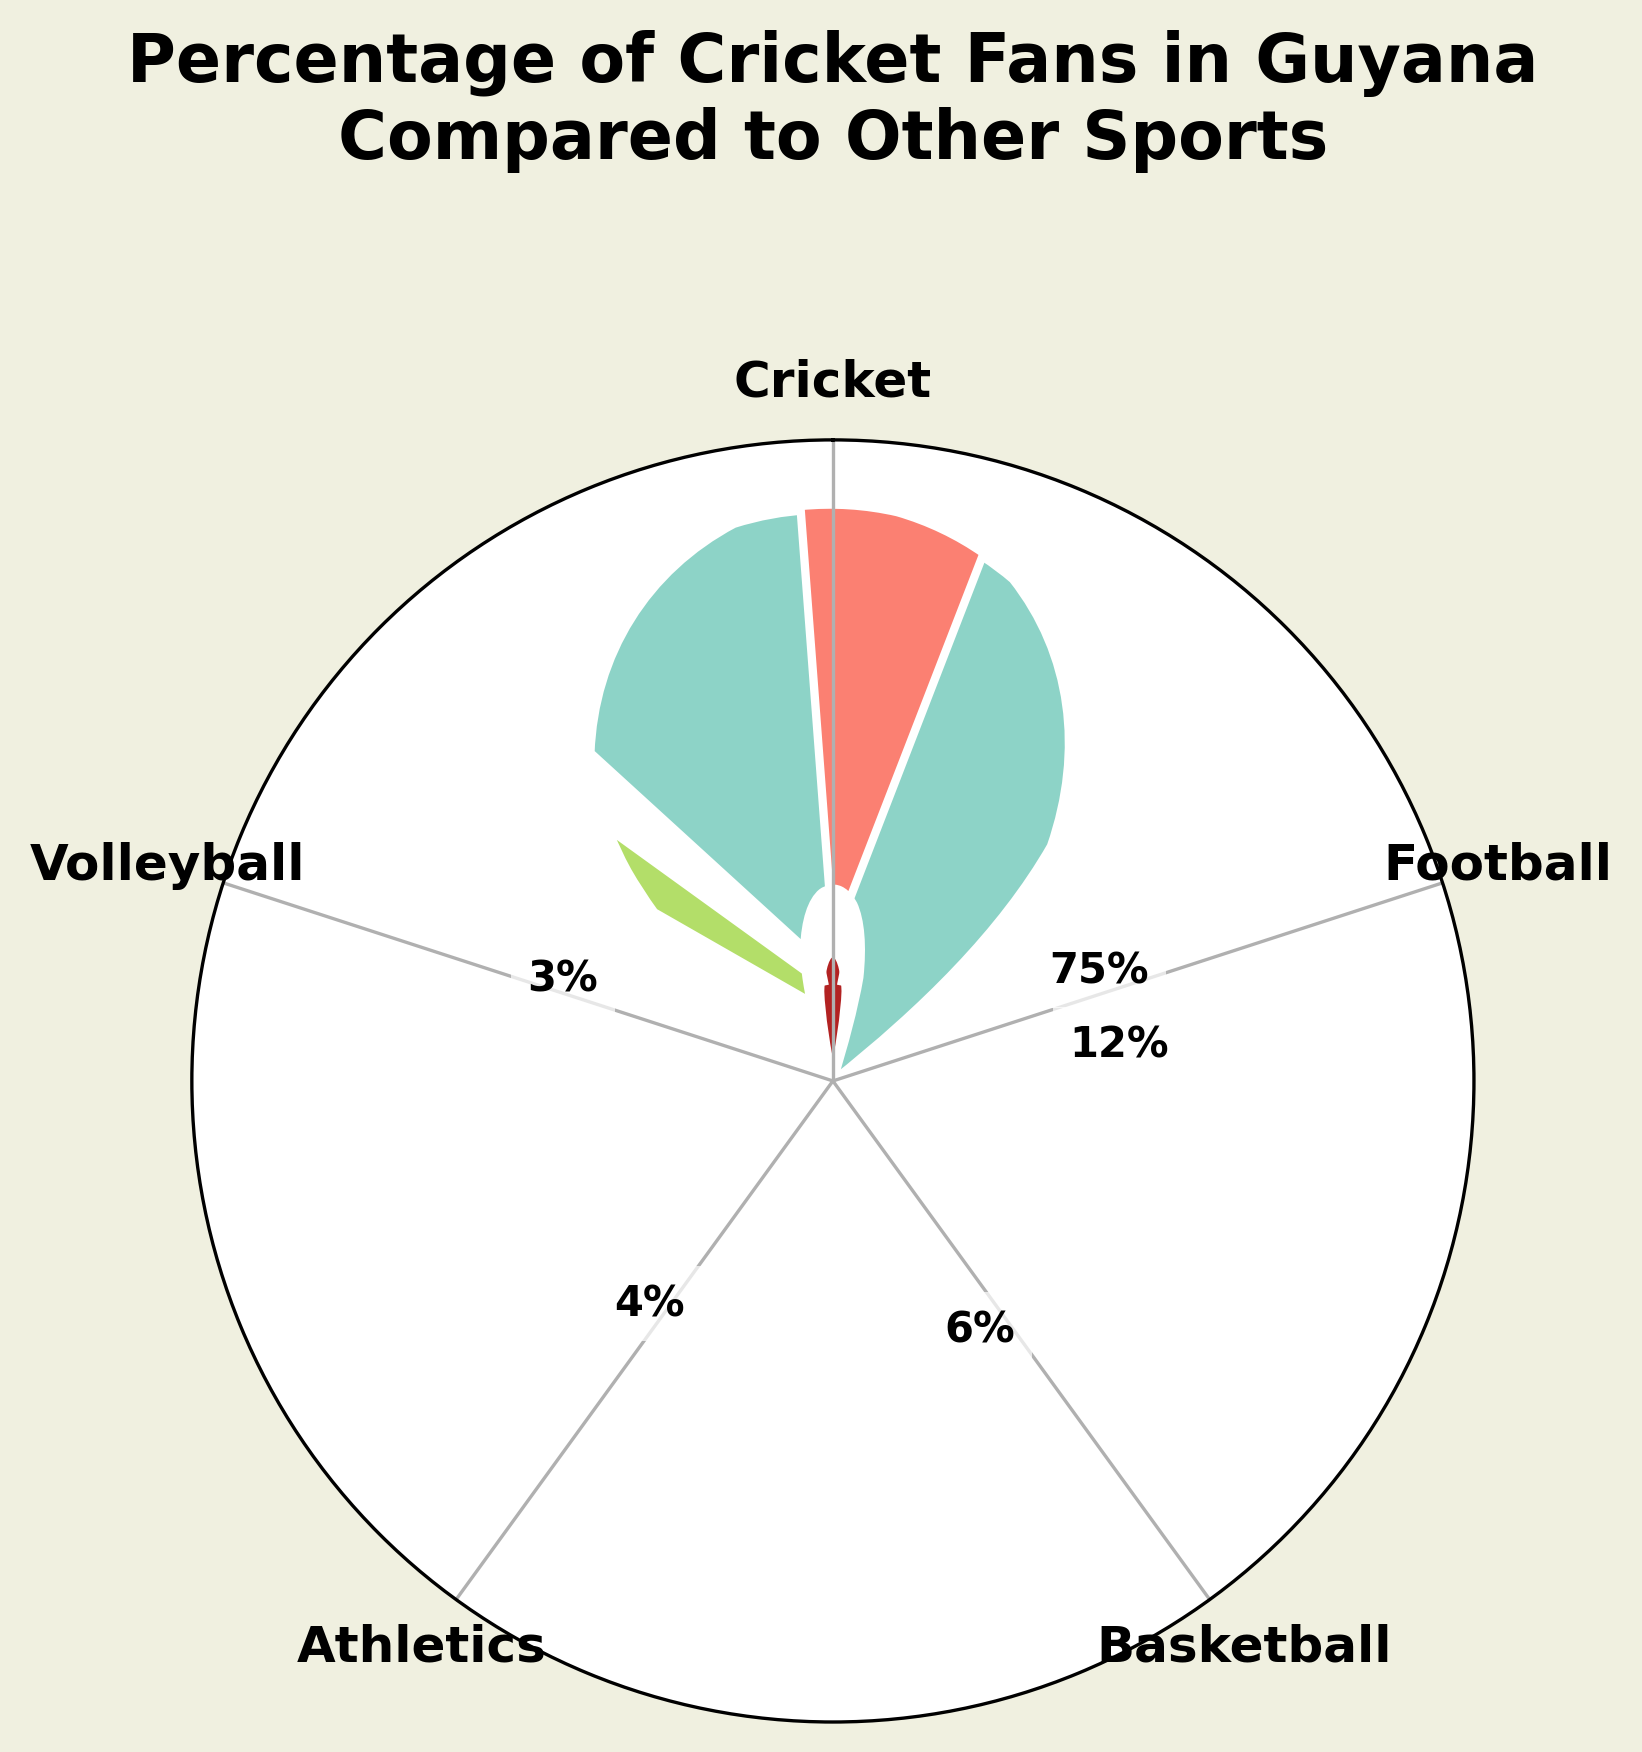What sport has the highest percentage of fans in Guyana? The largest sector on the gauge chart is for Cricket, which is the first in the sports list and occupies the biggest portion of the chart.
Answer: Cricket What is the total percentage of fans for Cricket and Football combined? Cricket has 75% and Football has 12%. Adding these two percentages, we get 75% + 12% = 87%.
Answer: 87% Which sport has the smallest percentage of fans? The smallest sector on the gauge chart corresponds to Volleyball, which occupies the smallest portion of the chart.
Answer: Volleyball How does the percentage of Cricket fans compare to the percentage of Football fans? Cricket has 75% of fans, while Football has 12%. Comparing these, 75% is much higher than 12%.
Answer: Cricket fans are more than Football fans What is the difference between the percentage of Cricket fans and Basketball fans? Cricket has 75% and Basketball has 6%. The difference between these two percentages is 75% - 6% = 69%.
Answer: 69% How are the sports arranged around the gauge? The sports are arranged clockwise starting with Football, followed by Basketball, Athletics, Volleyball, and finally Cricket.
Answer: Clockwise starting with Football What is the total percentage of fans for all sports except Cricket? The percentages of fans for sports other than Cricket (Football, Basketball, Athletics, and Volleyball) are 12%, 6%, 4%, and 3%. Adding these, 12% + 6% + 4% + 3% = 25%.
Answer: 25% Is there a sport with exactly half the percentage of fans compared to Athletics? Athletics has 4% of fans. Half of this percentage is 4% / 2 = 2%. None of the sports listed have exactly 2% fans.
Answer: No What is the combined percentage of fans for the two sports with the least popularity? The least popular sports are Volleyball with 3% and Athletics with 4%. Adding these, we get 3% + 4% = 7%.
Answer: 7% Which sport comes immediately after Football in the gauge chart sequence? The sports are arranged in the sequence Football, Basketball, Athletics, Volleyball, and Cricket. Therefore, Basketball comes immediately after Football.
Answer: Basketball 